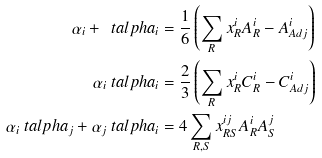<formula> <loc_0><loc_0><loc_500><loc_500>\alpha _ { i } + \ t a l p h a _ { i } & = \frac { 1 } { 6 } \left ( \sum _ { R } x ^ { i } _ { R } A _ { R } ^ { i } - A _ { A d j } ^ { i } \right ) \\ \alpha _ { i } \ t a l p h a _ { i } & = \frac { 2 } { 3 } \left ( \sum _ { R } x ^ { i } _ { R } C _ { R } ^ { i } - C _ { A d j } ^ { i } \right ) \\ \alpha _ { i } \ t a l p h a _ { j } + \alpha _ { j } \ t a l p h a _ { i } & = 4 \sum _ { R , S } x ^ { i j } _ { R S } A _ { R } ^ { i } A _ { S } ^ { j }</formula> 